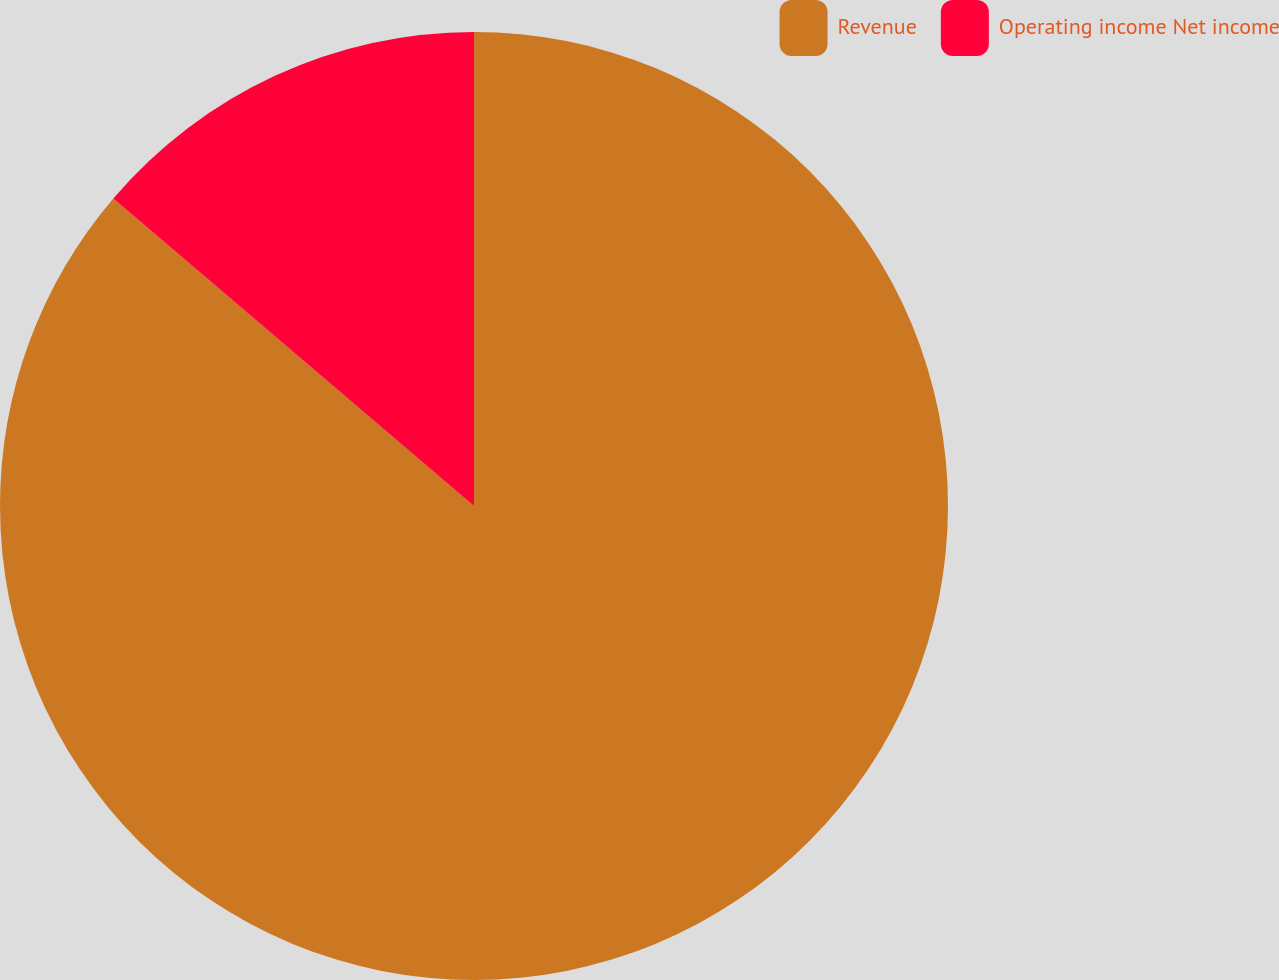Convert chart to OTSL. <chart><loc_0><loc_0><loc_500><loc_500><pie_chart><fcel>Revenue<fcel>Operating income Net income<nl><fcel>86.24%<fcel>13.76%<nl></chart> 